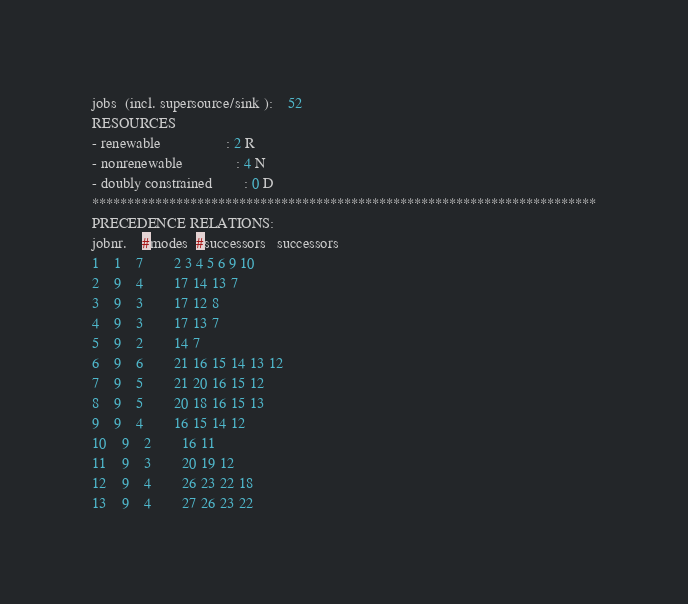<code> <loc_0><loc_0><loc_500><loc_500><_ObjectiveC_>jobs  (incl. supersource/sink ):	52
RESOURCES
- renewable                 : 2 R
- nonrenewable              : 4 N
- doubly constrained        : 0 D
************************************************************************
PRECEDENCE RELATIONS:
jobnr.    #modes  #successors   successors
1	1	7		2 3 4 5 6 9 10 
2	9	4		17 14 13 7 
3	9	3		17 12 8 
4	9	3		17 13 7 
5	9	2		14 7 
6	9	6		21 16 15 14 13 12 
7	9	5		21 20 16 15 12 
8	9	5		20 18 16 15 13 
9	9	4		16 15 14 12 
10	9	2		16 11 
11	9	3		20 19 12 
12	9	4		26 23 22 18 
13	9	4		27 26 23 22 </code> 